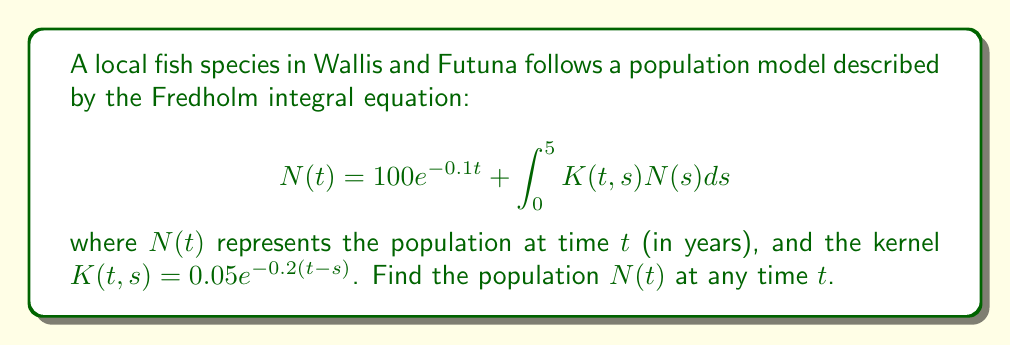What is the answer to this math problem? To solve this Fredholm integral equation, we'll use the method of successive approximations:

1) Start with the initial approximation:
   $$N_0(t) = 100e^{-0.1t}$$

2) Substitute this into the right-hand side of the equation:
   $$N_1(t) = 100e^{-0.1t} + \int_0^5 0.05e^{-0.2(t-s)}(100e^{-0.1s})ds$$

3) Evaluate the integral:
   $$N_1(t) = 100e^{-0.1t} + 5e^{-0.2t}\int_0^5 e^{0.1s}ds$$
   $$= 100e^{-0.1t} + 5e^{-0.2t}[\frac{1}{0.1}e^{0.1s}]_0^5$$
   $$= 100e^{-0.1t} + 50e^{-0.2t}(e^{0.5} - 1)$$

4) This process could be continued, but we'll stop here as the next iterations would only add smaller terms.

5) The solution can be approximated as:
   $$N(t) \approx 100e^{-0.1t} + 50e^{-0.2t}(e^{0.5} - 1)$$

This solution represents the population dynamics of the fish species over time, with an initial exponential decay modified by the integral term representing interactions within the population.
Answer: $N(t) \approx 100e^{-0.1t} + 50e^{-0.2t}(e^{0.5} - 1)$ 